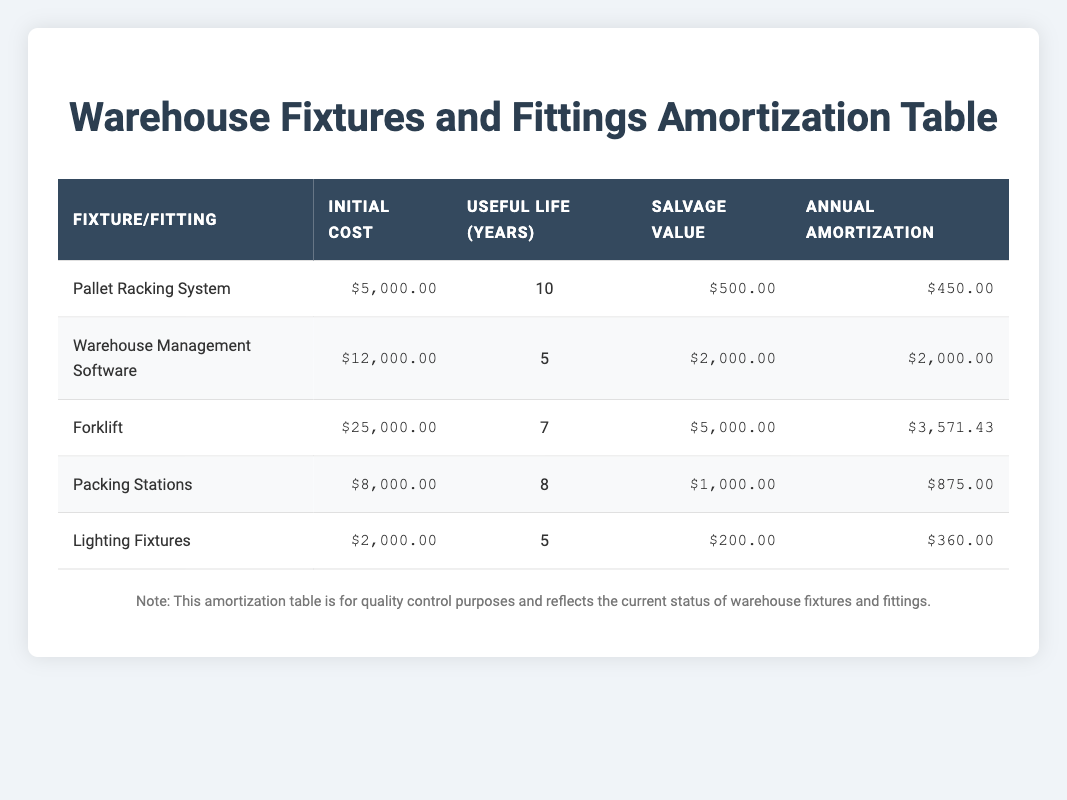What is the initial cost of the Forklift? The initial cost for the Forklift is directly listed in the table. You can find it in the row corresponding to the Forklift fixture.
Answer: 25000 How many years is the useful life of the Warehouse Management Software? The useful life of any item is provided in the respective column of the table. By locating the row for the Warehouse Management Software, the useful life is explicitly stated.
Answer: 5 Which fixture has the highest annual amortization? To find the fixture with the highest annual amortization, one must compare the values in the annual amortization column across all fixtures. Looking at that column, the Forklift has the highest value at 3571.43.
Answer: Forklift What is the total initial cost of all the fixtures and fittings? To calculate the total initial cost, I add up all the initial cost values from the table: 5000 + 12000 + 25000 + 8000 + 2000 = 50000.
Answer: 50000 Is the salvage value of the Packing Stations greater than that of the Lighting Fixtures? To answer this yes or no question, look for the salvage values in the table specifically for Packing Stations and Lighting Fixtures: Packing Stations has a salvage value of 1000, while Lighting Fixtures has a salvage value of 200. Since 1000 is greater than 200, the answer is yes.
Answer: Yes What is the average annual amortization for all the listed fixtures? To calculate the average annual amortization, first sum all the annual amortization values: 450 + 2000 + 3571.43 + 875 + 360 = 10356.43. Then divide this sum by the number of fixtures (5): 10356.43 / 5 = 2071.29.
Answer: 2071.29 Does the Pallet Racking System have a salvage value lower than 1000? According to the table, the salvage value for the Pallet Racking System is 500, which is indeed lower than 1000. Thus, the answer is yes.
Answer: Yes Which fixture has a useful life of 8 years? By scanning the useful life column in the table, I can identify which fixture corresponds to 8 years. This fixture is the Packing Stations.
Answer: Packing Stations If we consider a scenario where the initial cost of each fixture is reduced by 10%, what would the new initial cost of the Lighting Fixtures be? Start with the original initial cost of the Lighting Fixtures, which is 2000. Calculate 10% of 2000, which is 200, and then subtract that from the initial cost: 2000 - 200 = 1800.
Answer: 1800 